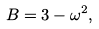<formula> <loc_0><loc_0><loc_500><loc_500>B = 3 - \omega ^ { 2 } ,</formula> 